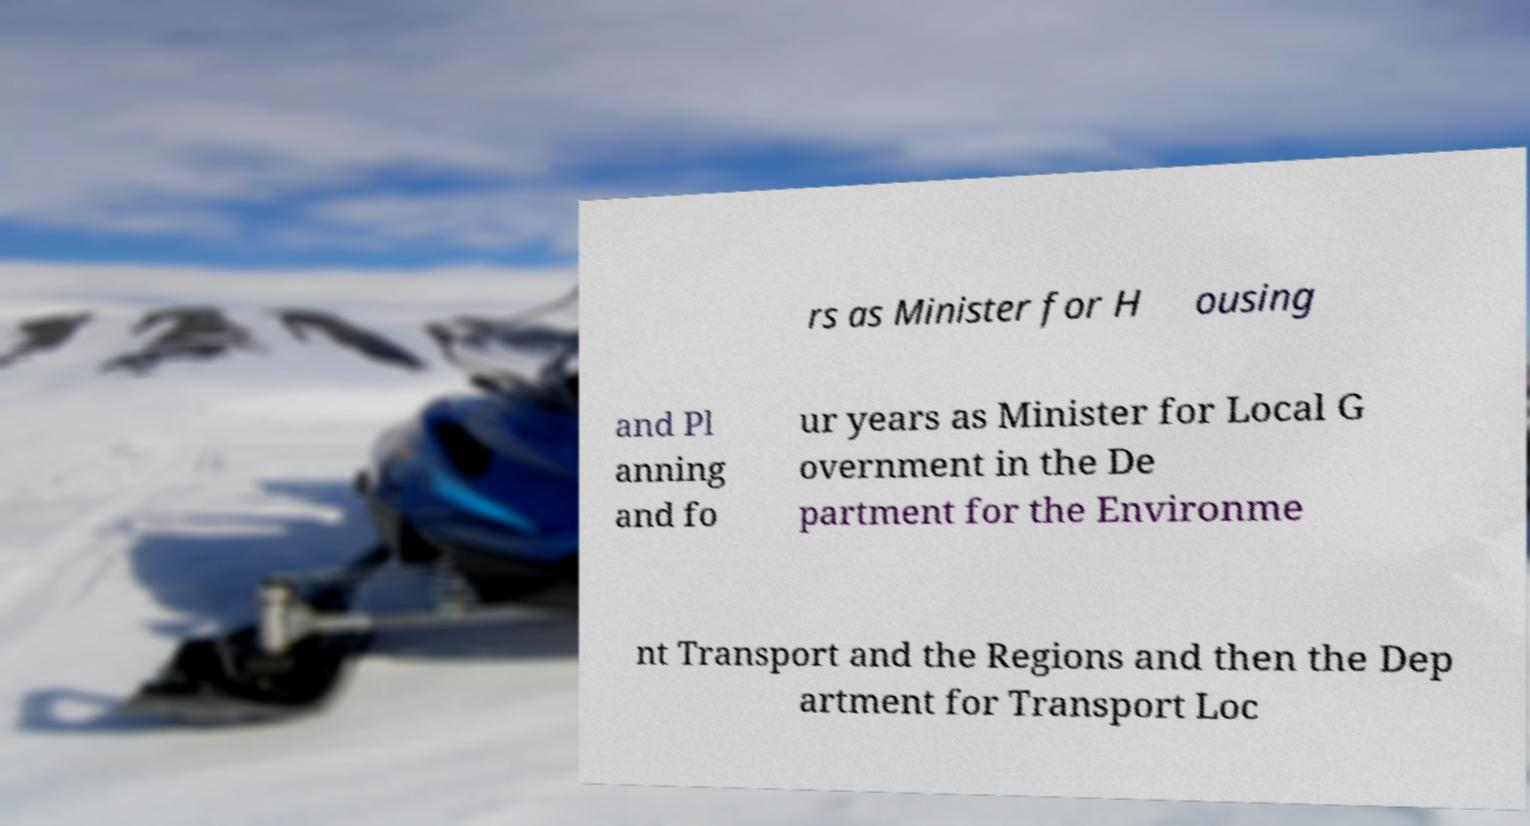There's text embedded in this image that I need extracted. Can you transcribe it verbatim? rs as Minister for H ousing and Pl anning and fo ur years as Minister for Local G overnment in the De partment for the Environme nt Transport and the Regions and then the Dep artment for Transport Loc 